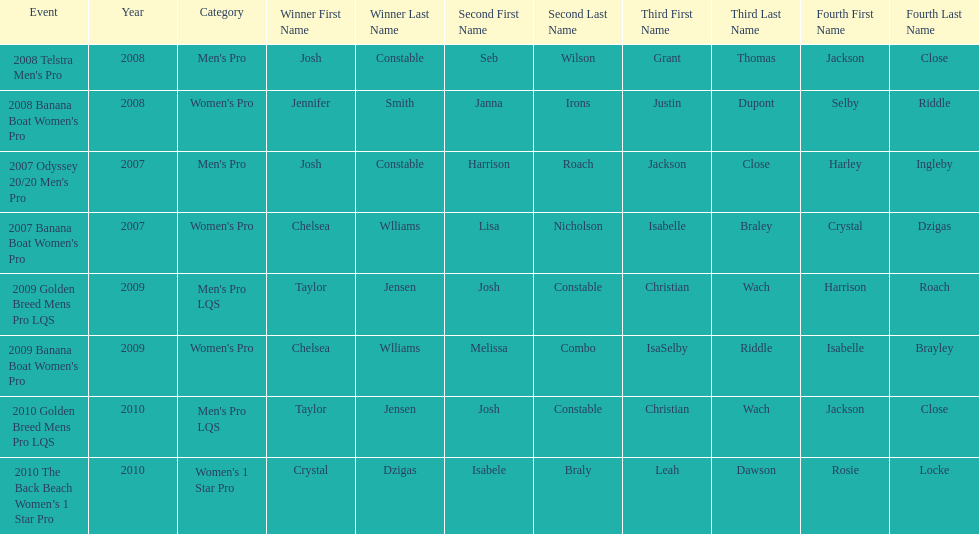Who was next to finish after josh constable in the 2008 telstra men's pro? Seb Wilson. Parse the full table. {'header': ['Event', 'Year', 'Category', 'Winner First Name', 'Winner Last Name', 'Second First Name', 'Second Last Name', 'Third First Name', 'Third Last Name', 'Fourth First Name', 'Fourth Last Name'], 'rows': [["2008 Telstra Men's Pro", '2008', "Men's Pro", 'Josh', 'Constable', 'Seb', 'Wilson', 'Grant', 'Thomas', 'Jackson', 'Close'], ["2008 Banana Boat Women's Pro", '2008', "Women's Pro", 'Jennifer', 'Smith', 'Janna', 'Irons', 'Justin', 'Dupont', 'Selby', 'Riddle'], ["2007 Odyssey 20/20 Men's Pro", '2007', "Men's Pro", 'Josh', 'Constable', 'Harrison', 'Roach', 'Jackson', 'Close', 'Harley', 'Ingleby'], ["2007 Banana Boat Women's Pro", '2007', "Women's Pro", 'Chelsea', 'Wlliams', 'Lisa', 'Nicholson', 'Isabelle', 'Braley', 'Crystal', 'Dzigas'], ['2009 Golden Breed Mens Pro LQS', '2009', "Men's Pro LQS", 'Taylor', 'Jensen', 'Josh', 'Constable', 'Christian', 'Wach', 'Harrison', 'Roach'], ["2009 Banana Boat Women's Pro", '2009', "Women's Pro", 'Chelsea', 'Wlliams', 'Melissa', 'Combo', 'IsaSelby', 'Riddle', 'Isabelle', 'Brayley'], ['2010 Golden Breed Mens Pro LQS', '2010', "Men's Pro LQS", 'Taylor', 'Jensen', 'Josh', 'Constable', 'Christian', 'Wach', 'Jackson', 'Close'], ['2010 The Back Beach Women’s 1 Star Pro', '2010', "Women's 1 Star Pro", 'Crystal', 'Dzigas', 'Isabele', 'Braly', 'Leah', 'Dawson', 'Rosie', 'Locke']]} 